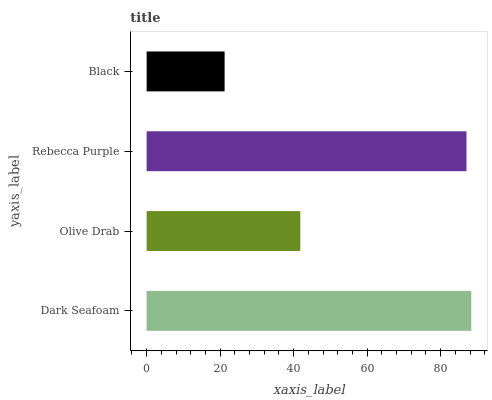Is Black the minimum?
Answer yes or no. Yes. Is Dark Seafoam the maximum?
Answer yes or no. Yes. Is Olive Drab the minimum?
Answer yes or no. No. Is Olive Drab the maximum?
Answer yes or no. No. Is Dark Seafoam greater than Olive Drab?
Answer yes or no. Yes. Is Olive Drab less than Dark Seafoam?
Answer yes or no. Yes. Is Olive Drab greater than Dark Seafoam?
Answer yes or no. No. Is Dark Seafoam less than Olive Drab?
Answer yes or no. No. Is Rebecca Purple the high median?
Answer yes or no. Yes. Is Olive Drab the low median?
Answer yes or no. Yes. Is Black the high median?
Answer yes or no. No. Is Black the low median?
Answer yes or no. No. 